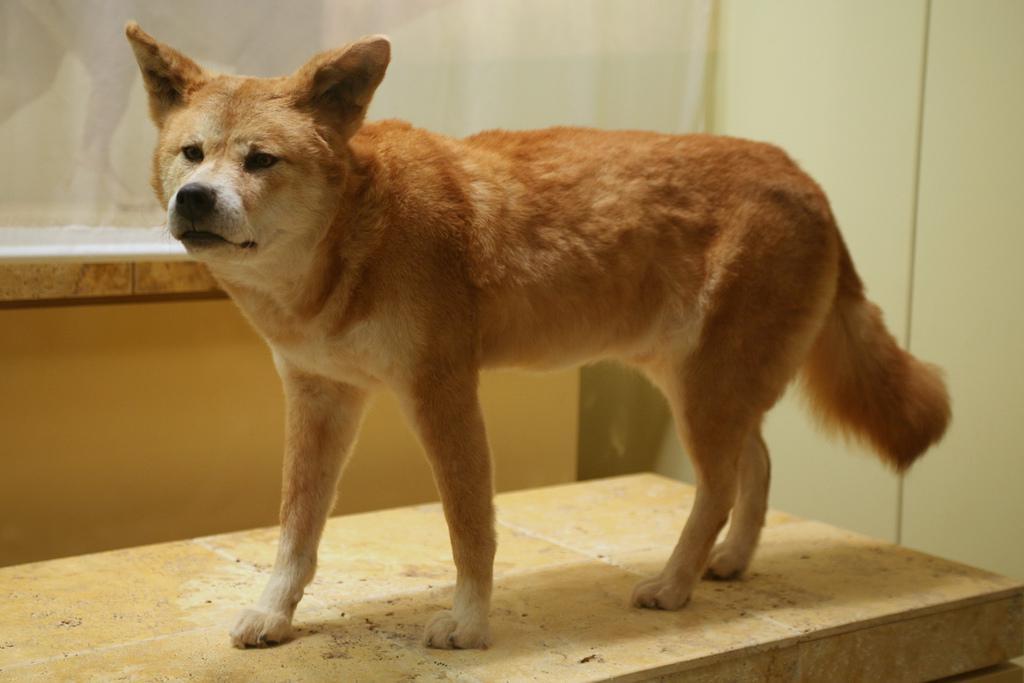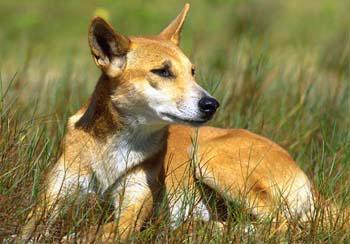The first image is the image on the left, the second image is the image on the right. Given the left and right images, does the statement "the animal in the image on the left is standing on all fours." hold true? Answer yes or no. Yes. The first image is the image on the left, the second image is the image on the right. For the images displayed, is the sentence "In the right image, one canine is lying on the grass." factually correct? Answer yes or no. Yes. 